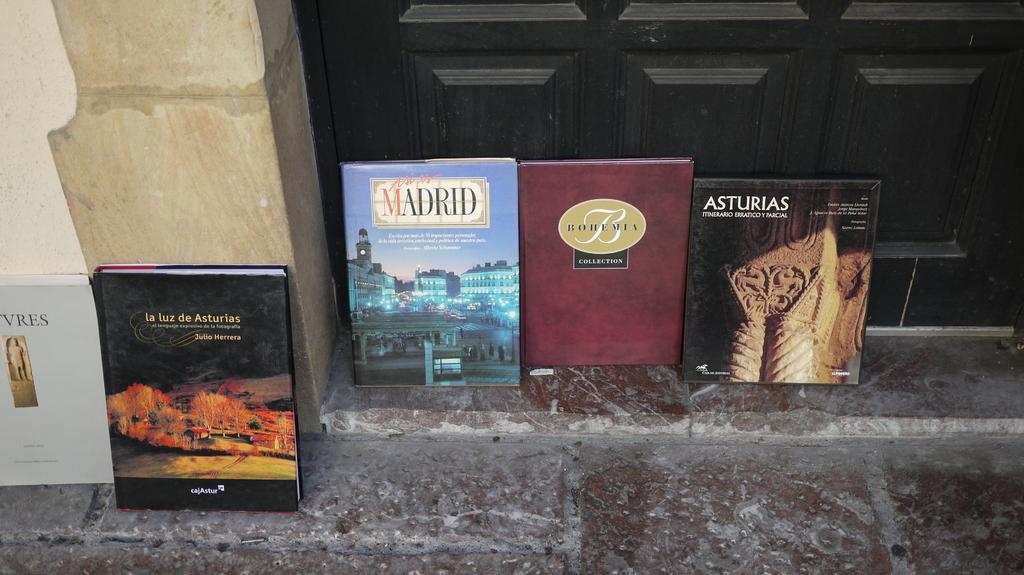<image>
Write a terse but informative summary of the picture. A book about Madrid sits on a stone floor with a few other books. 